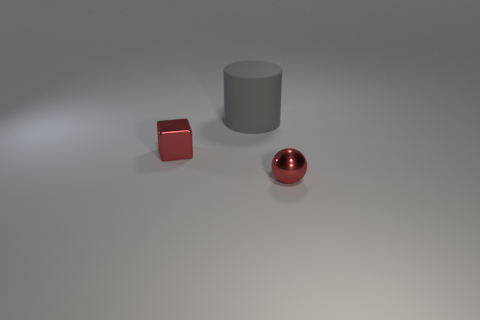Subtract 1 gray cylinders. How many objects are left? 2 Subtract all cylinders. How many objects are left? 2 Subtract all blue cubes. Subtract all gray spheres. How many cubes are left? 1 Subtract all purple blocks. How many gray spheres are left? 0 Subtract all large gray rubber objects. Subtract all large objects. How many objects are left? 1 Add 3 shiny cubes. How many shiny cubes are left? 4 Add 1 large blue shiny cylinders. How many large blue shiny cylinders exist? 1 Add 2 big gray things. How many objects exist? 5 